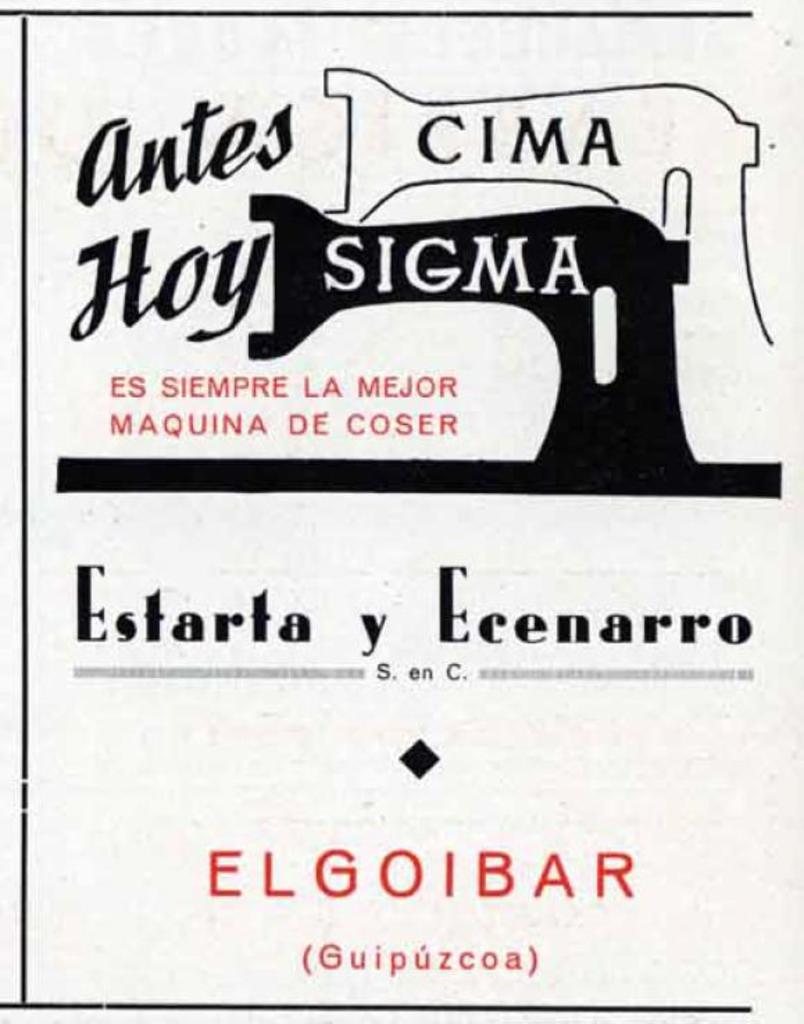What word appears in parenthesis?
Provide a short and direct response. Guipuzcoa. What is the title?
Give a very brief answer. Estarta y ecenarro. 